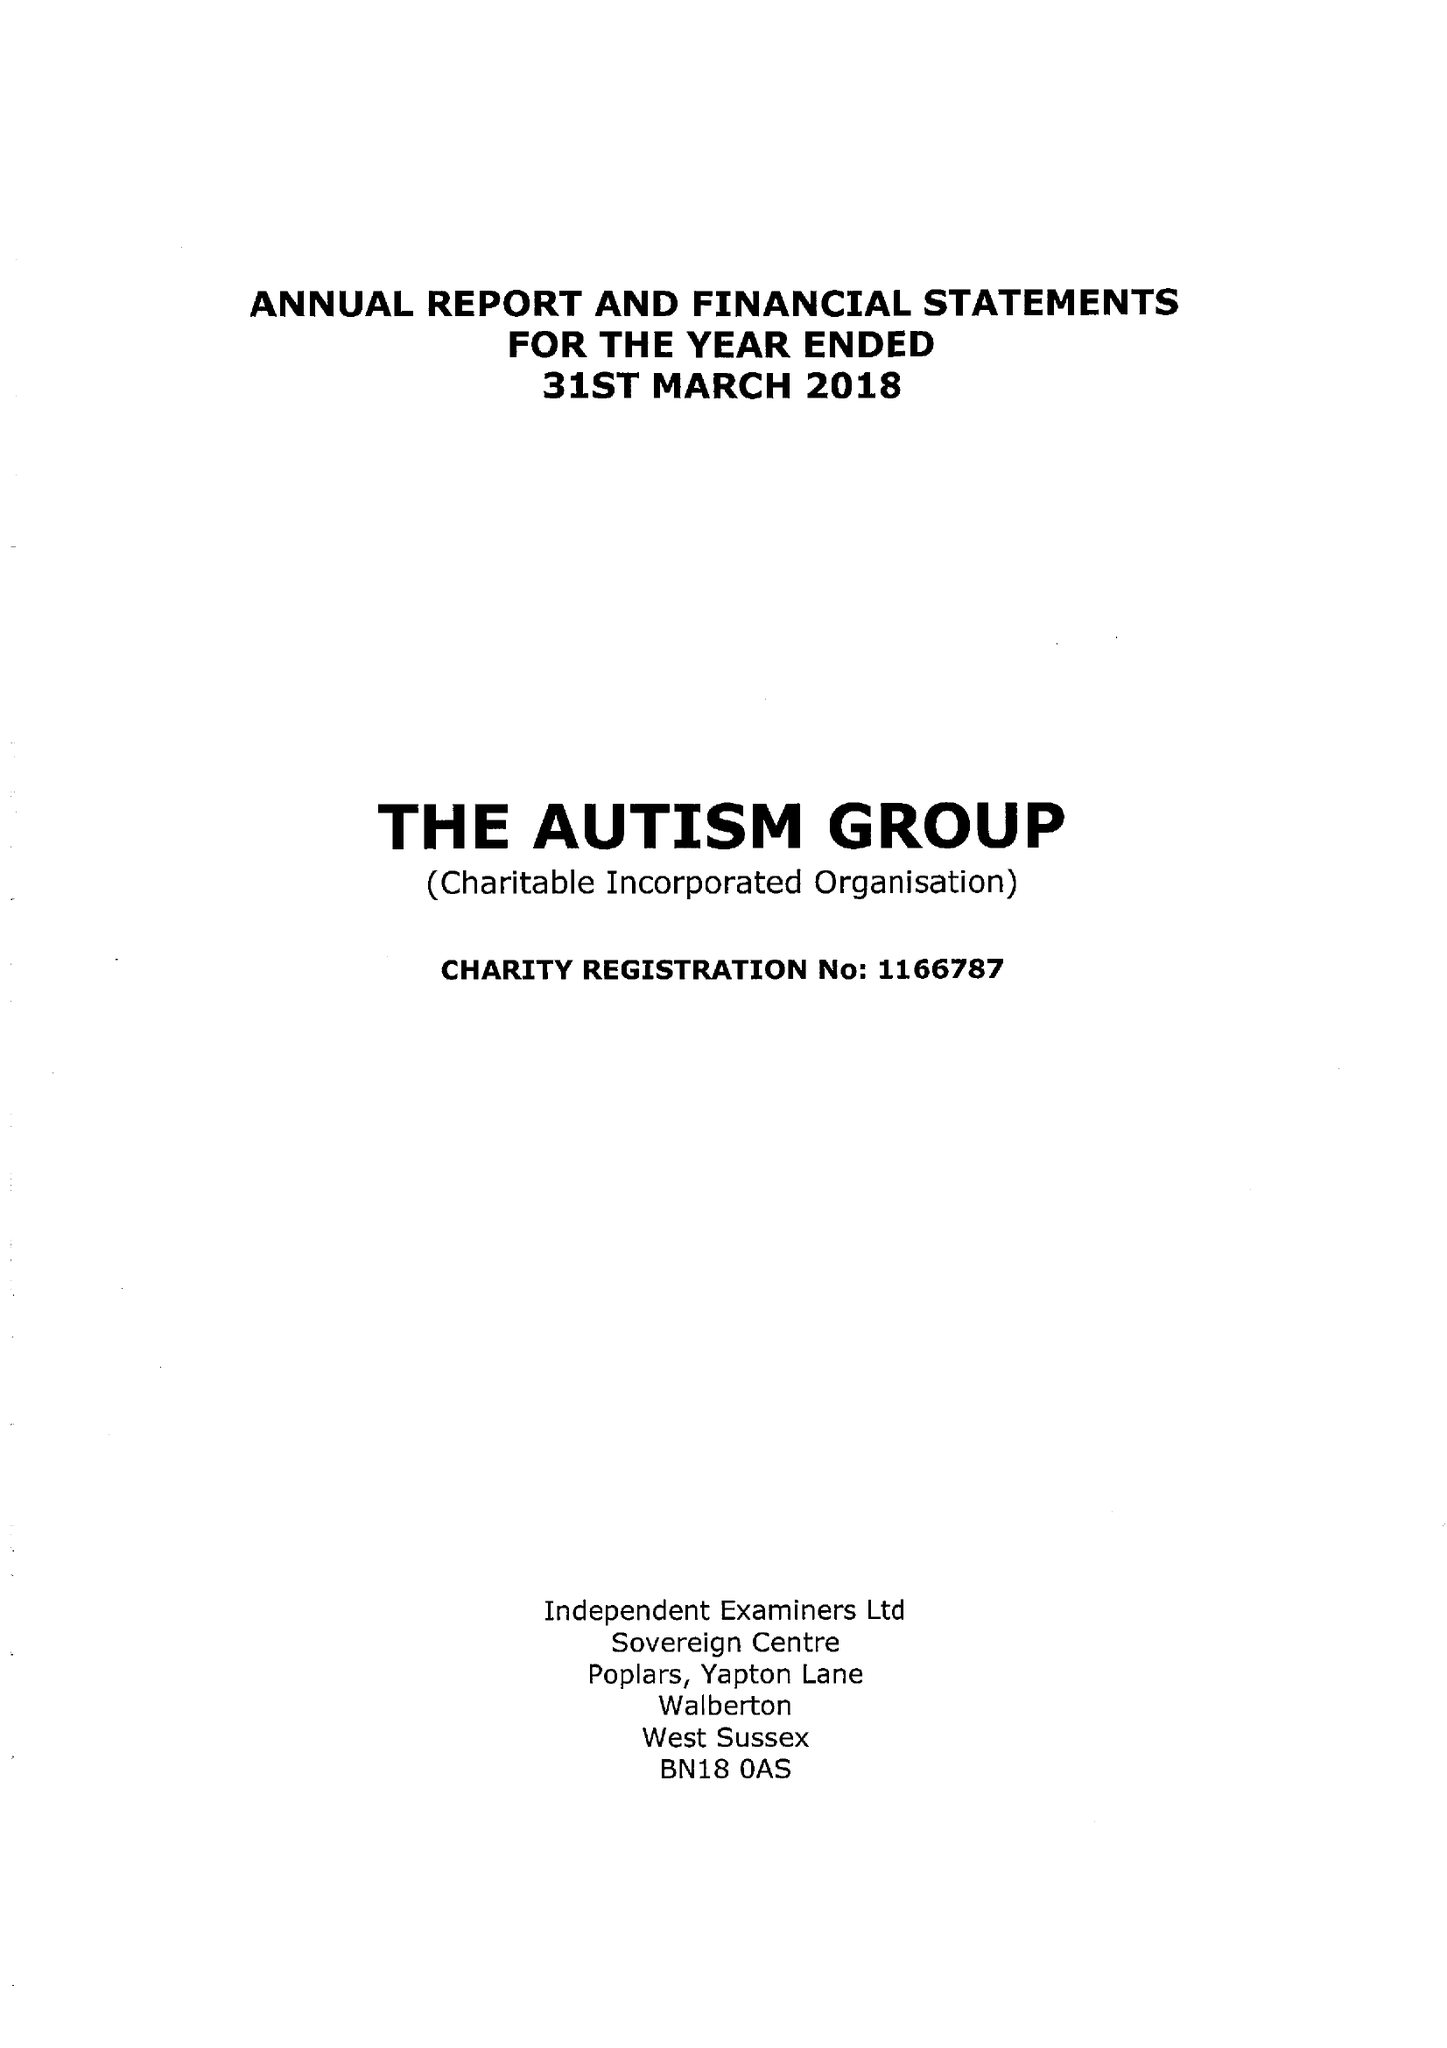What is the value for the spending_annually_in_british_pounds?
Answer the question using a single word or phrase. 39857.00 